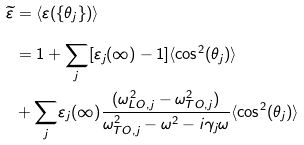Convert formula to latex. <formula><loc_0><loc_0><loc_500><loc_500>\widetilde { \varepsilon } & = \langle \varepsilon ( \{ \theta _ { j } \} ) \rangle \\ & = 1 + \underset { j } { \sum } [ \varepsilon _ { j } ( \infty ) - 1 ] \langle \cos ^ { 2 } ( \theta _ { j } ) \rangle \\ & + \underset { j } { \sum } \varepsilon _ { j } ( \infty ) \frac { ( \omega _ { L O , j } ^ { 2 } - \omega _ { T O , j } ^ { 2 } ) } { \omega _ { T O , j } ^ { 2 } - \omega ^ { 2 } - i \gamma _ { j } \omega } \langle \cos ^ { 2 } ( \theta _ { j } ) \rangle</formula> 